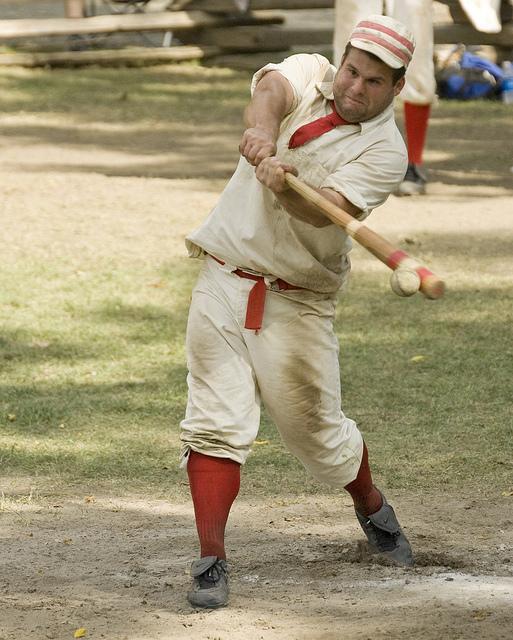Which country headquarters the brand company of this man's shoes?
Pick the correct solution from the four options below to address the question.
Options: China, india, united states, italy. United states. 